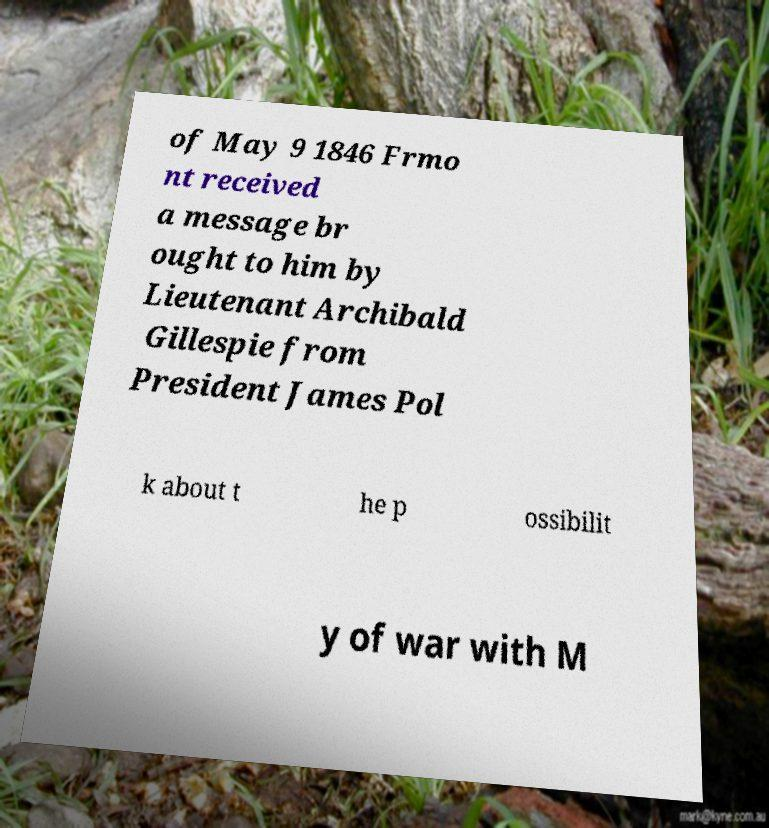Please identify and transcribe the text found in this image. of May 9 1846 Frmo nt received a message br ought to him by Lieutenant Archibald Gillespie from President James Pol k about t he p ossibilit y of war with M 